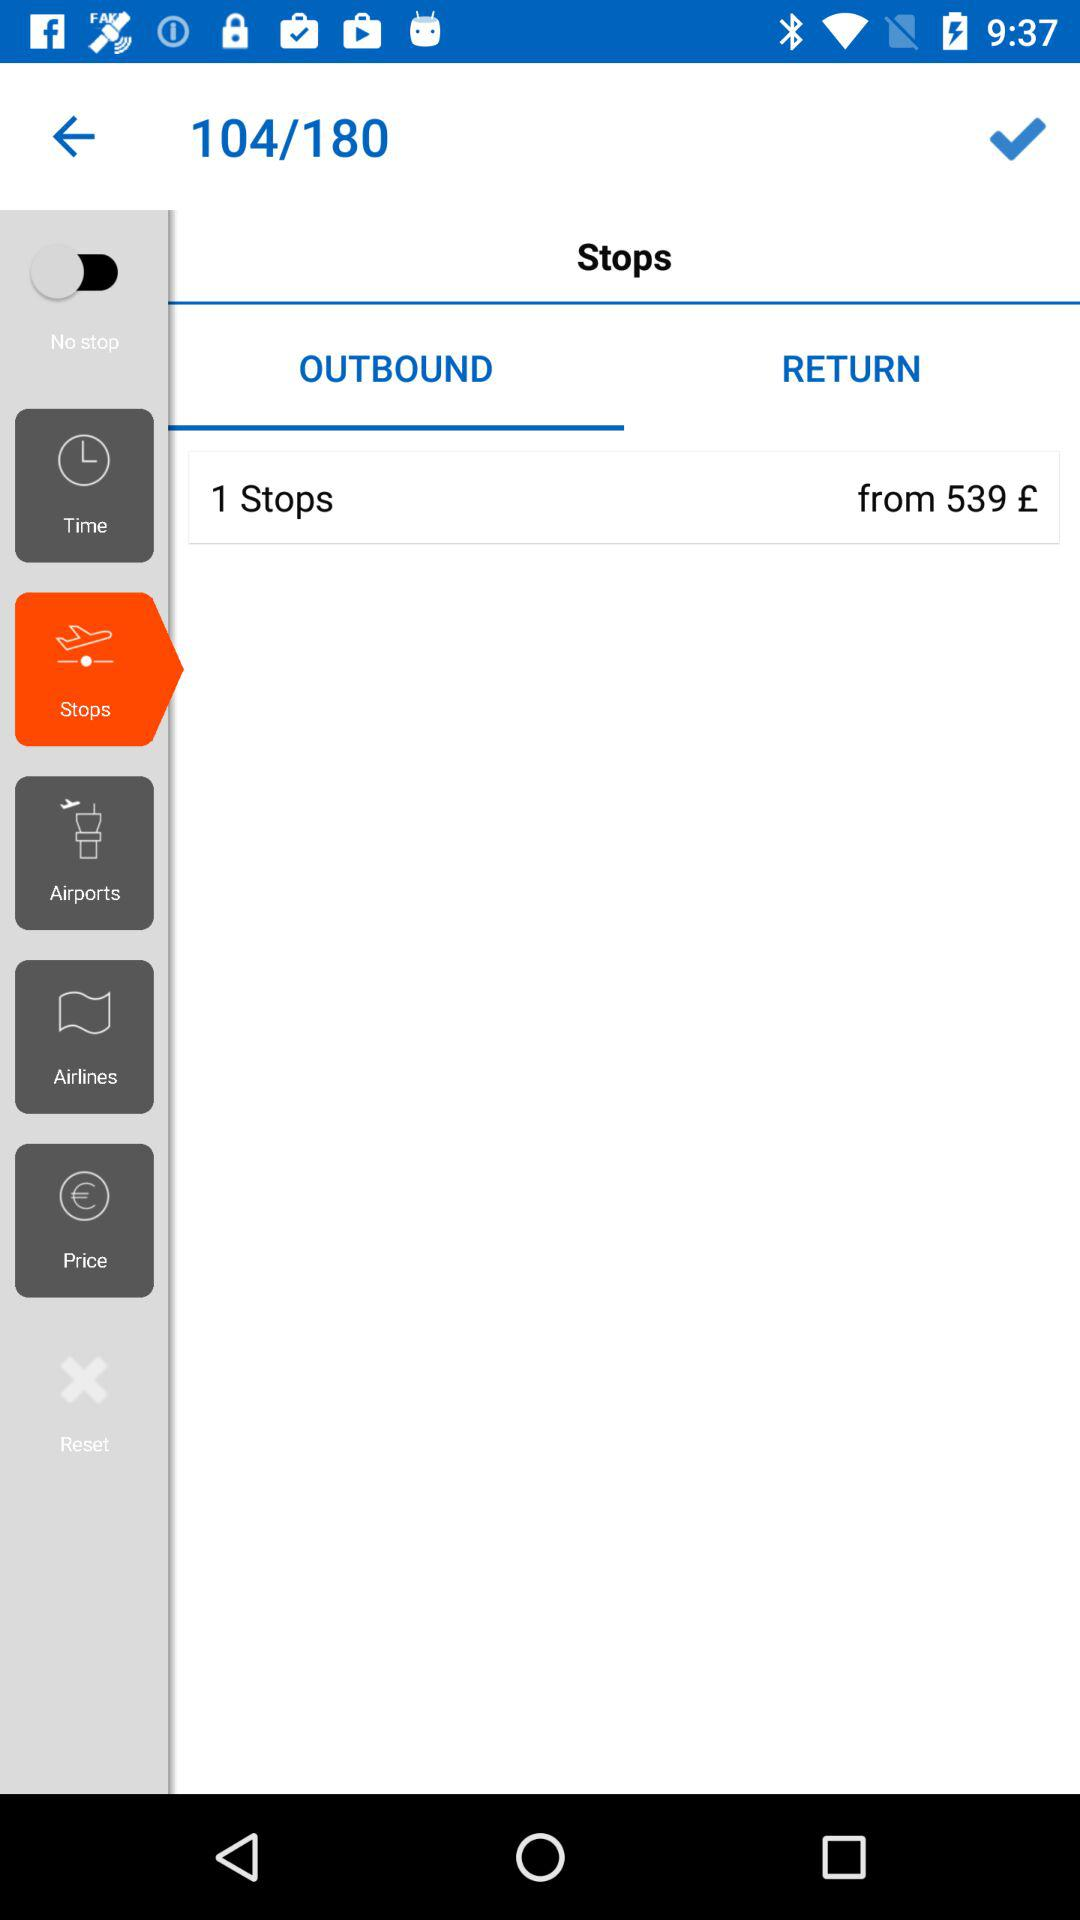What is the layover amount for "1 Stops"? The layover amount for "1 Stops" starts from 539 pounds. 